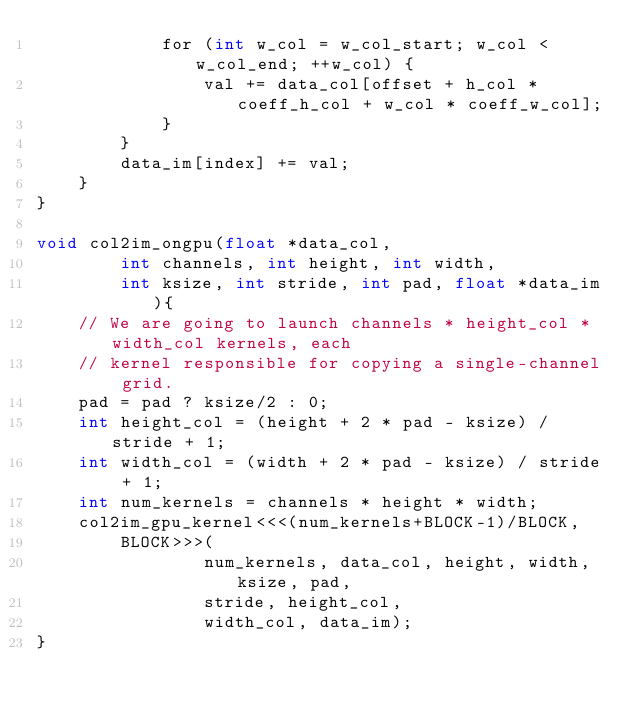<code> <loc_0><loc_0><loc_500><loc_500><_Cuda_>            for (int w_col = w_col_start; w_col < w_col_end; ++w_col) {
                val += data_col[offset + h_col * coeff_h_col + w_col * coeff_w_col];
            }
        }
        data_im[index] += val;
    }
}

void col2im_ongpu(float *data_col,
        int channels, int height, int width,
        int ksize, int stride, int pad, float *data_im){
    // We are going to launch channels * height_col * width_col kernels, each
    // kernel responsible for copying a single-channel grid.
    pad = pad ? ksize/2 : 0;
    int height_col = (height + 2 * pad - ksize) / stride + 1;
    int width_col = (width + 2 * pad - ksize) / stride + 1;
    int num_kernels = channels * height * width;
    col2im_gpu_kernel<<<(num_kernels+BLOCK-1)/BLOCK,
        BLOCK>>>(
                num_kernels, data_col, height, width, ksize, pad,
                stride, height_col,
                width_col, data_im);
}
</code> 